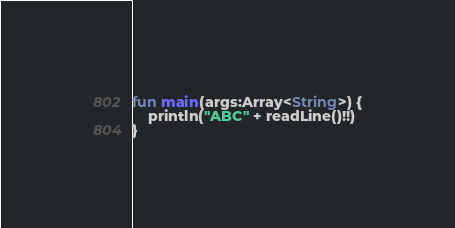Convert code to text. <code><loc_0><loc_0><loc_500><loc_500><_Kotlin_>fun main(args:Array<String>) {
    println("ABC" + readLine()!!)
}
</code> 